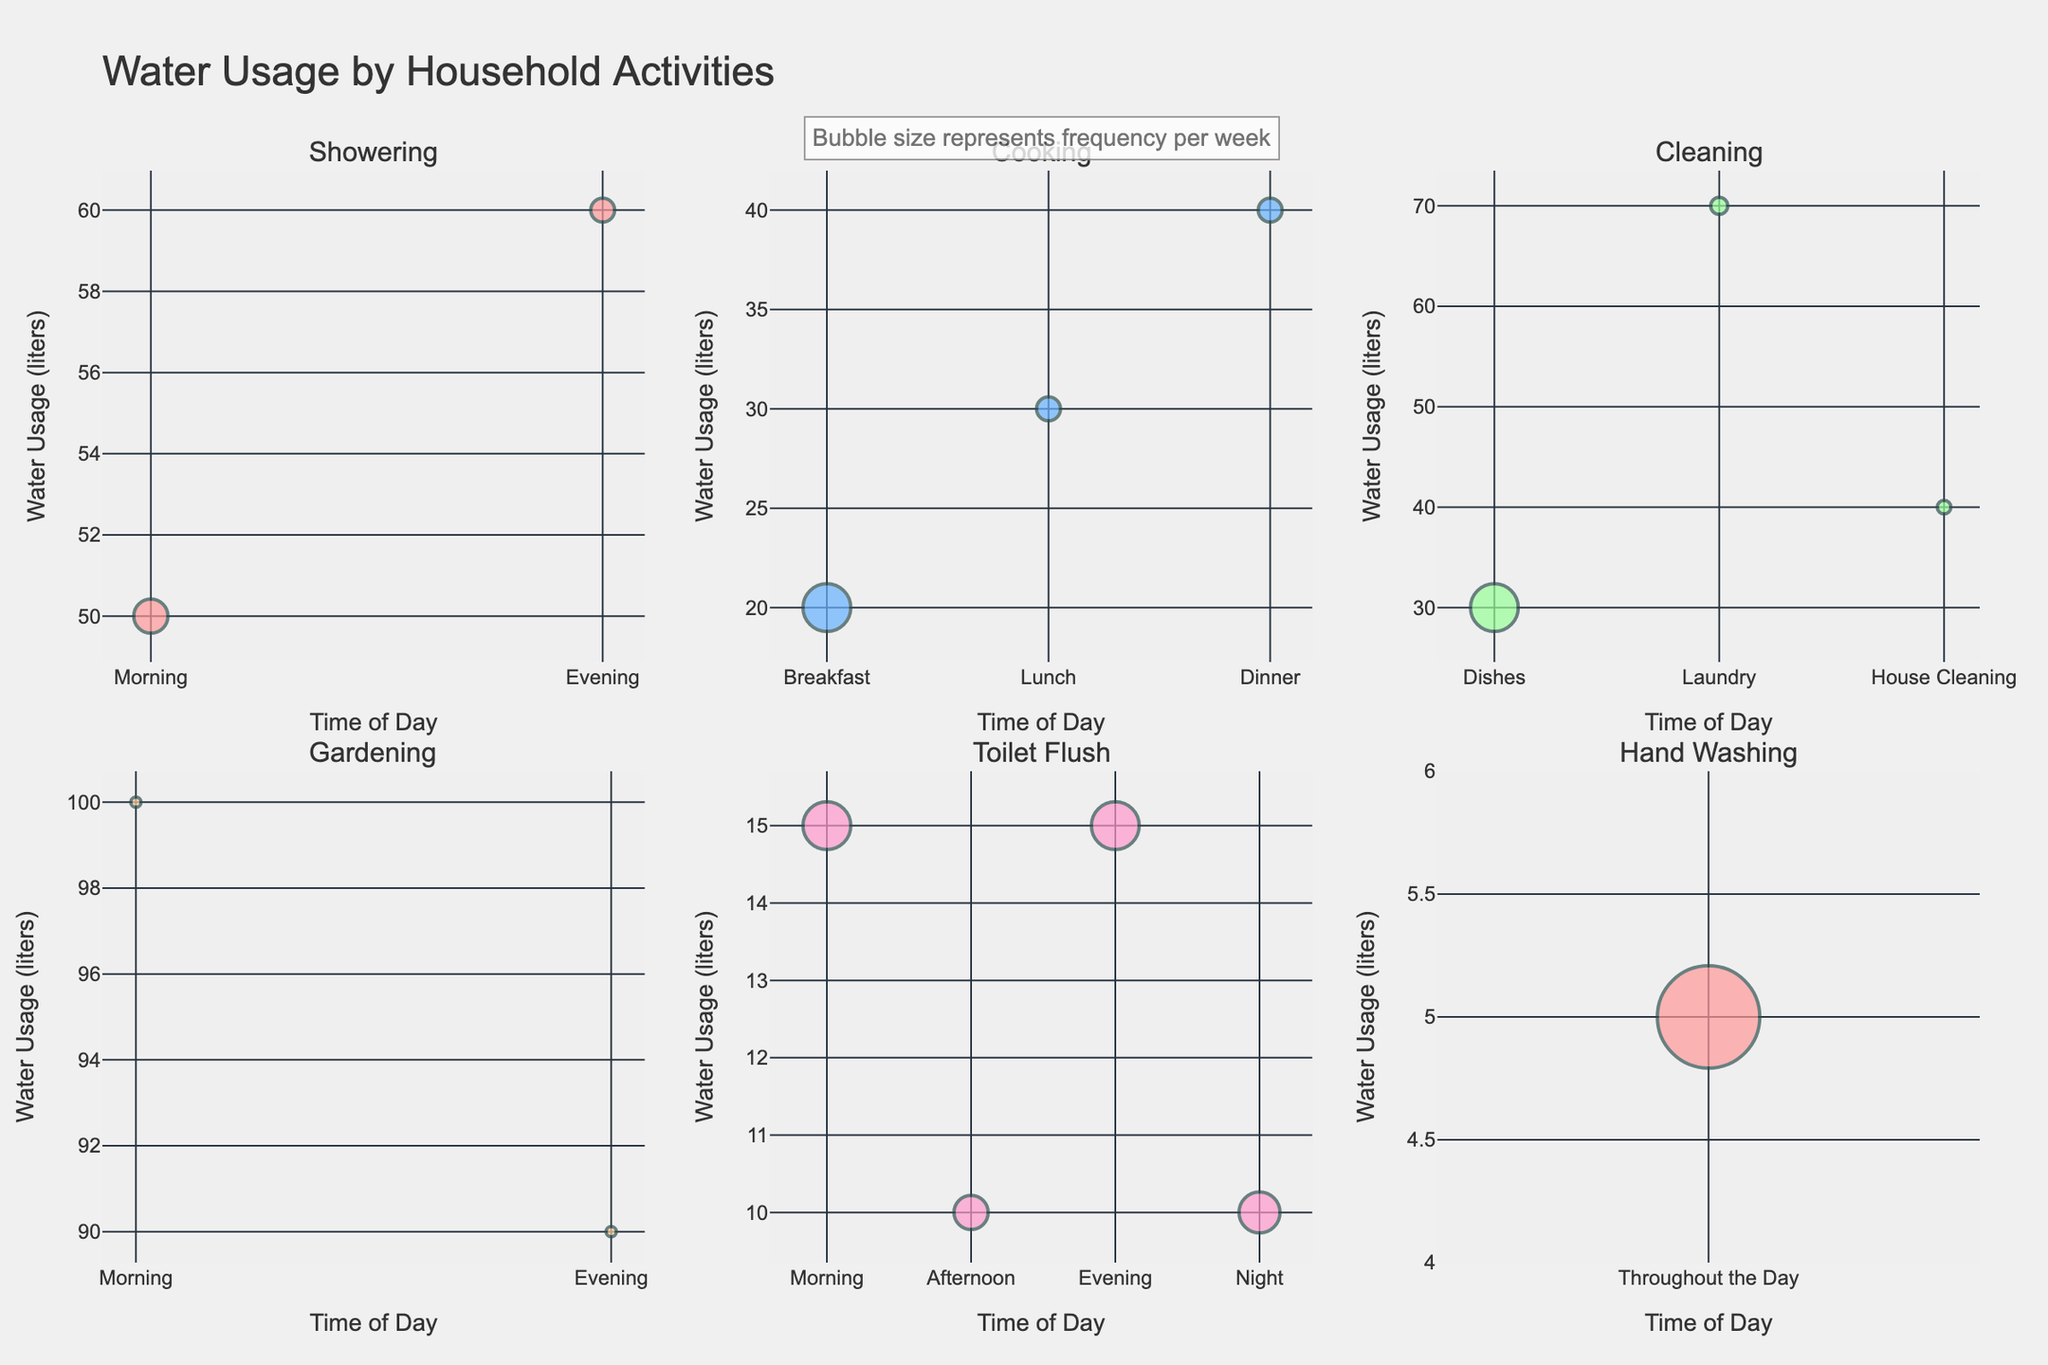What is the title of the chart? The title of the chart is displayed at the top center of the figure and provides an overview of the data being presented.
Answer: Water Usage by Household Activities What is the maximum water usage for Showering in the Evening? The bubble chart for Showering in the Evening shows the size and label corresponding to the water usage.
Answer: 60 liters Which activity uses the most water in the Morning? By comparing the bubbles in the Morning across different activities, the one with the largest water usage can be identified.
Answer: Gardening How many activities are plotted in the subplots in total? Count the number of subplot titles, each representing a different activity, in the figure.
Answer: 7 activities During which time of day is the highest water usage for Cooking? Look at the Cooking bubbles across different times of day for the largest water usage value.
Answer: Dinner Which activity has the least frequent occurrence throughout the week? Compare the bubble sizes across all subplots to find which has the smallest bubble.
Answer: House Cleaning What is the total water usage for Cooking in a week? Sum the water usage for Breakfast, Lunch, and Dinner by adding the corresponding values in the subplot. Calculation: 20 + 30 + 40 = 90 liters
Answer: 90 liters What is the most frequent activity per week, and how do you know this from the chart? Identify the bubble with the largest frequency, indicated by the size and possibly the text label showing times per week.
Answer: Hand Washing (30 times/week) How does the water usage for Toilet Flush vary by time of day? Observe the bubble sizes and positions in the Toilet Flush subplot to describe the variations.
Answer: Morning and Evening: 15 liters, Afternoon and Night: 10 liters Which two activities have the highest and lowest water usage in the Evening? Compare the water usage values in the Evening for all activities and identify the highest and lowest.
Answer: Highest: Gardening (90 liters), Lowest: Toilet Flush (15 liters) 